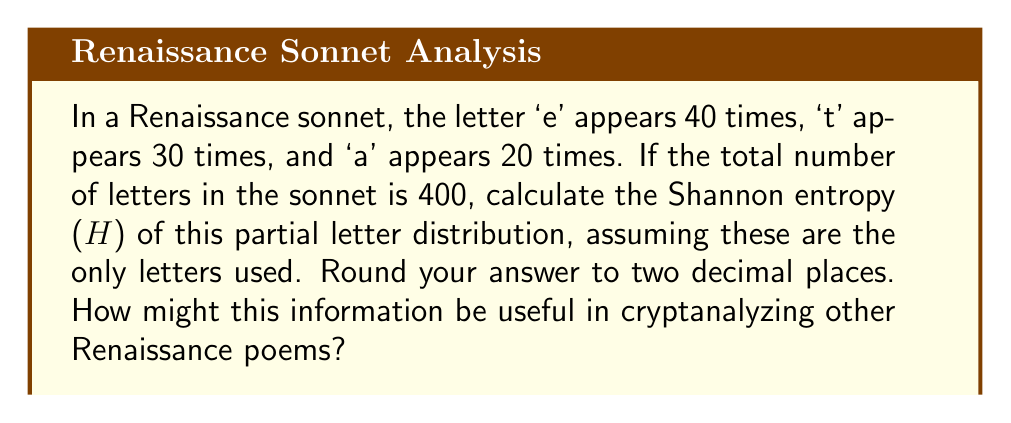Give your solution to this math problem. To solve this problem, we'll follow these steps:

1. Calculate the probabilities of each letter:
   $p(e) = 40/400 = 0.1$
   $p(t) = 30/400 = 0.075$
   $p(a) = 20/400 = 0.05$
   $p(\text{other}) = 1 - (0.1 + 0.075 + 0.05) = 0.775$

2. Apply the Shannon entropy formula:
   $$H = -\sum_{i} p_i \log_2(p_i)$$

3. Calculate each term:
   $-0.1 \log_2(0.1) = 0.332$
   $-0.075 \log_2(0.075) = 0.287$
   $-0.05 \log_2(0.05) = 0.216$
   $-0.775 \log_2(0.775) = 0.287$

4. Sum the terms:
   $H = 0.332 + 0.287 + 0.216 + 0.287 = 1.122$

5. Round to two decimal places: 1.12

This information can be useful in cryptanalyzing other Renaissance poems because:
a) It provides a baseline for letter frequency distribution in Renaissance poetry.
b) Unusual deviations from this distribution in encrypted texts might indicate the use of substitution ciphers.
c) The entropy value gives an idea of the predictability of letter occurrences, which can be used to estimate the strength of potential encryption methods used in that era.
Answer: 1.12 